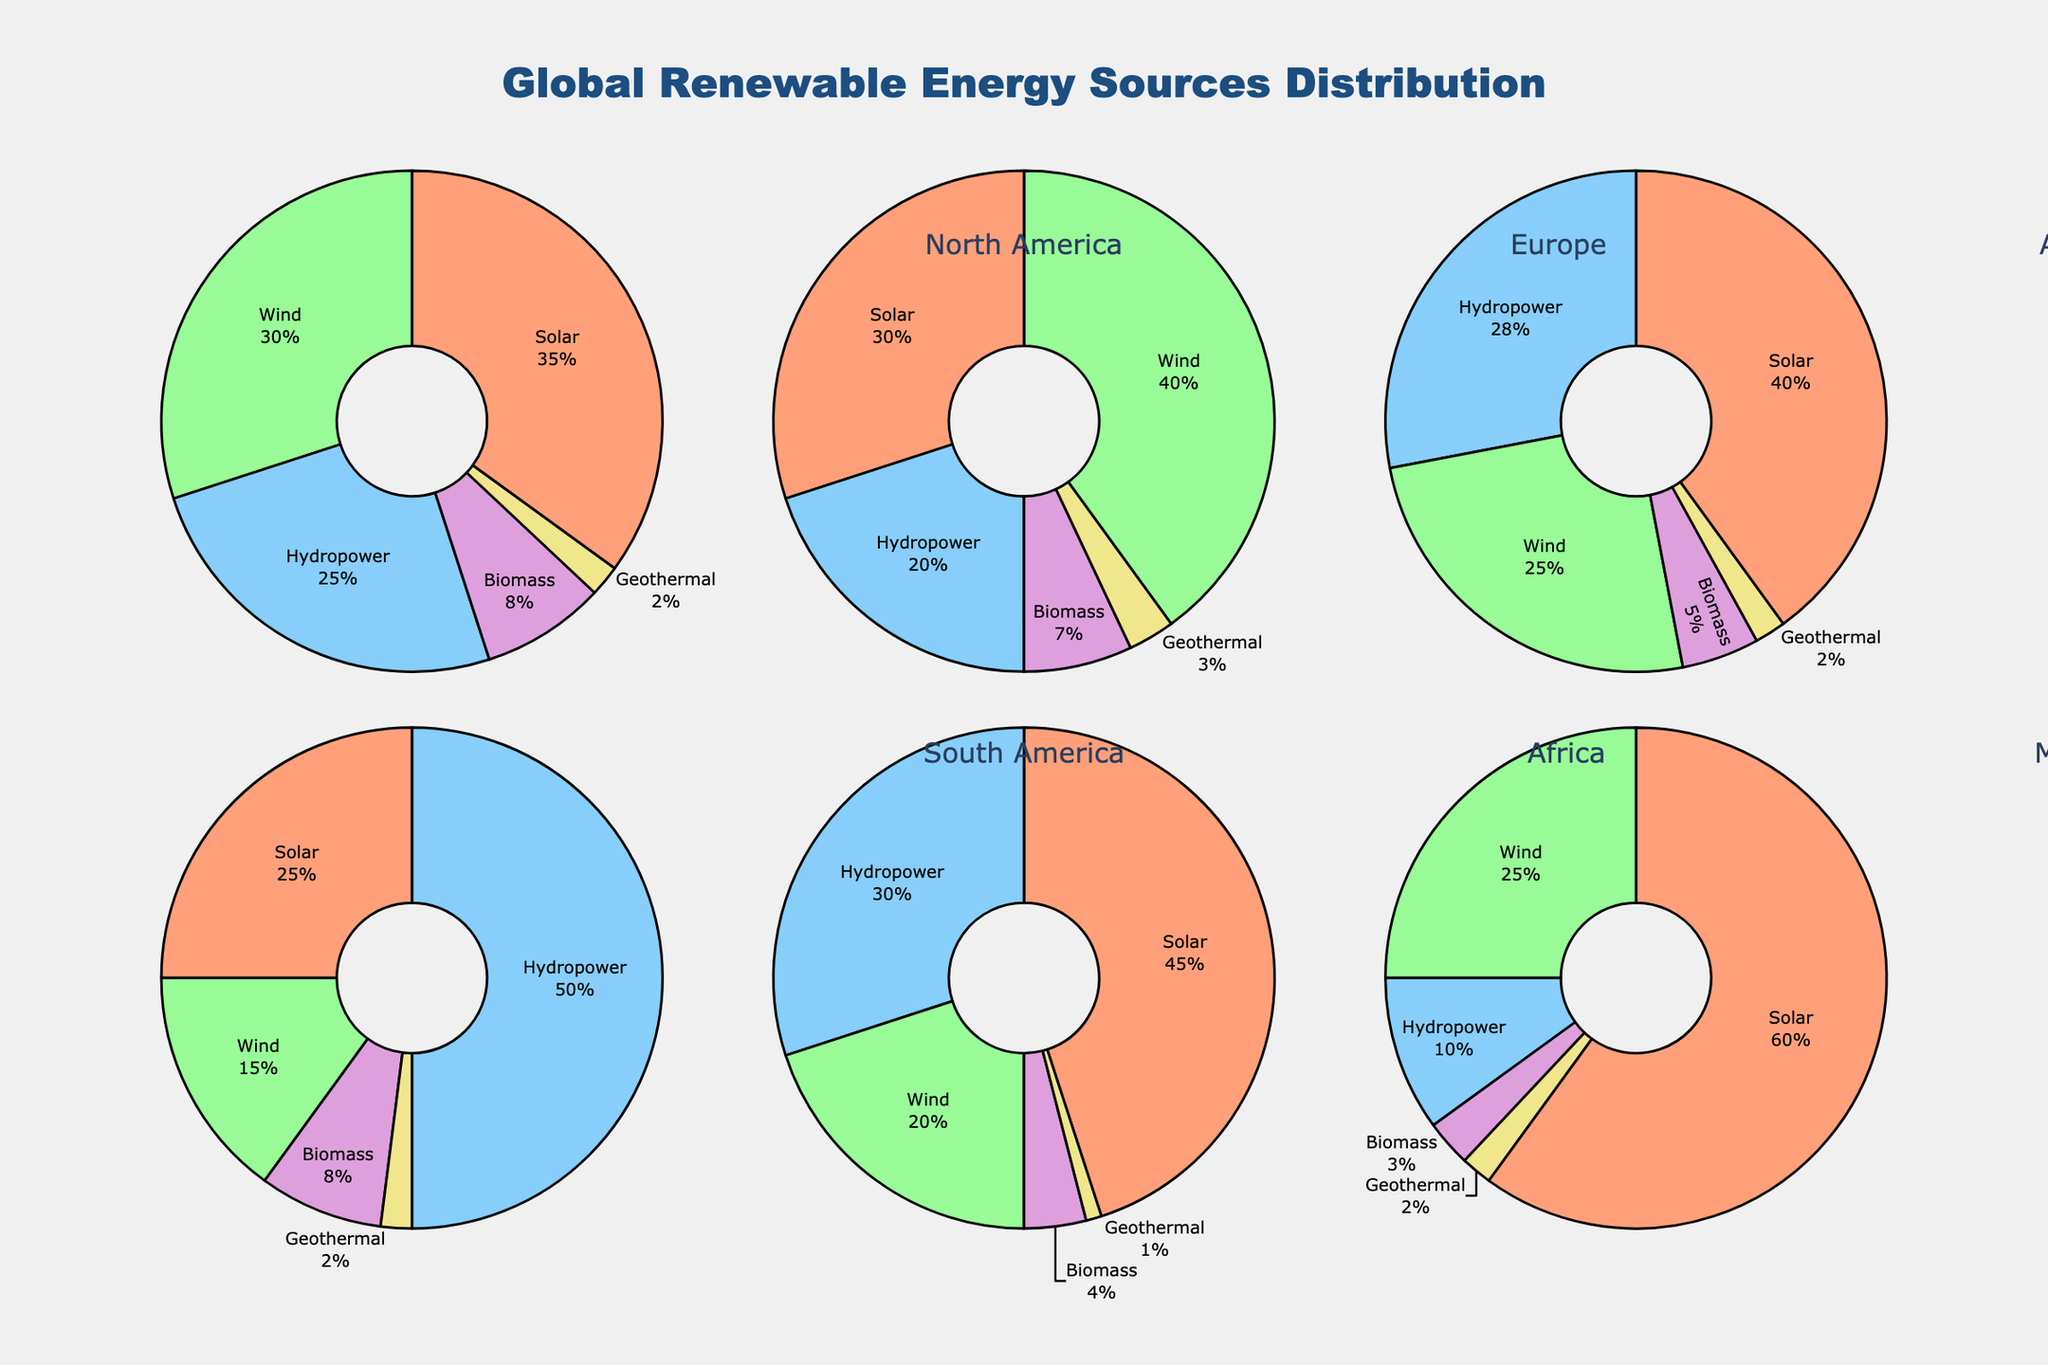Which region has the highest percentage of solar energy? By looking at each pie chart, we find that the Middle East has the highest percentage with 60% solar energy.
Answer: Middle East Which region has the highest wind energy contribution? On inspecting the pie charts, Europe has the highest percentage of wind energy at 40%.
Answer: Europe What is the combined percentage of biomass energy in South America and Africa? In South America, biomass accounts for 8% and in Africa, it's 4%. Adding them together gives 8% + 4% = 12%.
Answer: 12% Which energy source has the least contribution in the African region? The pie chart for Africa shows that Geothermal energy has the smallest contribution at 1%.
Answer: Geothermal How does the percentage of hydropower in Asia Pacific compare to that in North America? The pie chart shows that Asia Pacific has 28% hydropower while North America has 25%. Since 28% is greater than 25%, Asia Pacific has a higher percentage.
Answer: Asia Pacific has more Which regions have more than 20% wind energy? From the pie charts, North America, Europe, Asia Pacific, Africa, and the Middle East all have more than 20% wind energy.
Answer: North America, Europe, Asia Pacific, Africa, Middle East In which region does hydropower account for the largest percentage of renewable energy? Reviewing the pie charts, South America shows the highest percentage of hydropower at 50%.
Answer: South America What is the average percentage of solar energy across all regions? Calculate the average by summing the solar percentages (35 + 30 + 40 + 25 + 45 + 60) and dividing by the number of regions (6). That gives (35 + 30 + 40 + 25 + 45 + 60) / 6 = 38.33%.
Answer: 38.33% Which region has the smallest contribution from biomass and geothermal combined? Adding biomass and geothermal for each region, the Middle East has 3% biomass + 2% geothermal = 5%, which is the smallest.
Answer: Middle East Does any region have equal percentages for solar and wind energy? No region has the same percentage for solar and wind energy. Each pie chart shows different values for these energy sources.
Answer: No 